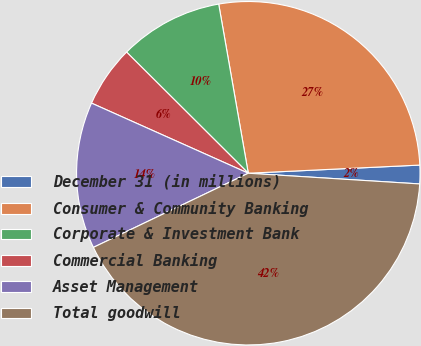Convert chart. <chart><loc_0><loc_0><loc_500><loc_500><pie_chart><fcel>December 31 (in millions)<fcel>Consumer & Community Banking<fcel>Corporate & Investment Bank<fcel>Commercial Banking<fcel>Asset Management<fcel>Total goodwill<nl><fcel>1.75%<fcel>27.0%<fcel>9.78%<fcel>5.77%<fcel>13.8%<fcel>41.9%<nl></chart> 